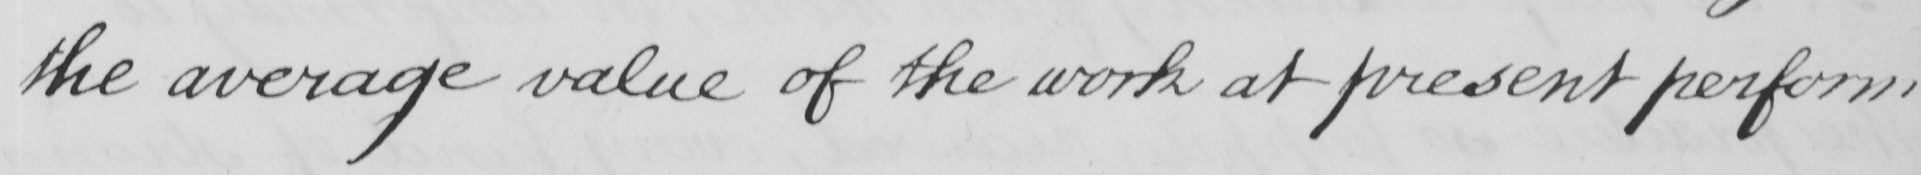Please provide the text content of this handwritten line. the average value of the work at present perform 